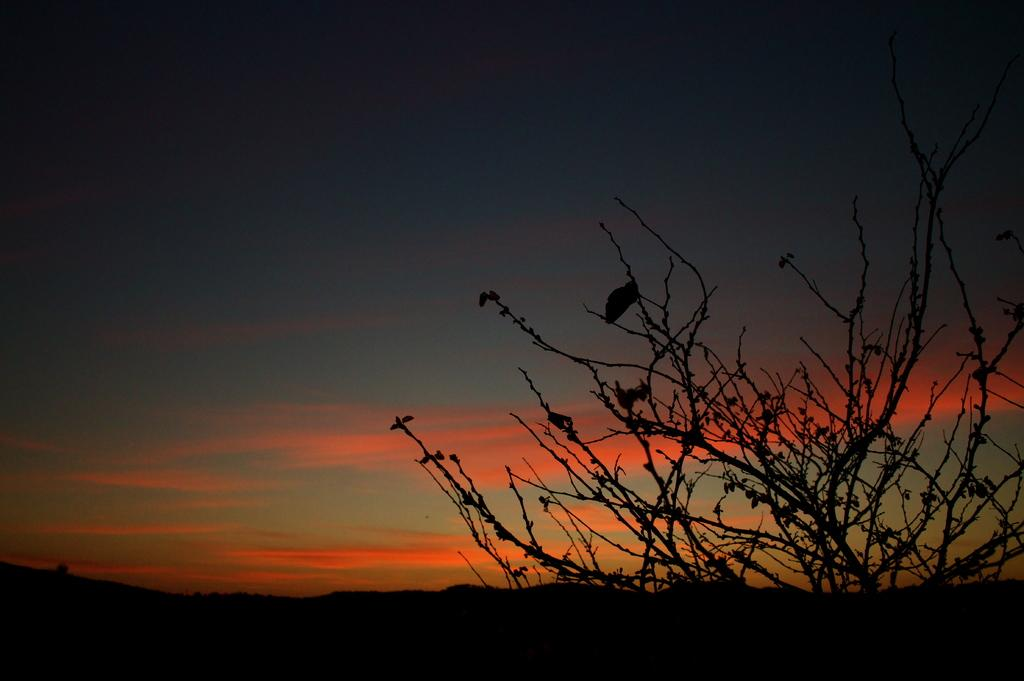What is located on the right side of the image? There is a tree with leaves in the foreground of the image. What can be seen in the background of the image? The sky is visible in the background of the image. What is present in the sky? There is a cloud in the sky. What is the condition of the tree in the image? The condition of the tree cannot be determined from the image alone, as it only shows the tree with leaves. --- Facts: 1. There is a person sitting on a bench in the image. 2. The person is reading a book. 3. The bench is in a park. 4. There are trees in the park. 5. There is a pond in the park. Absurd Topics: dance, parrot, mountain Conversation: What is the person in the image doing? The person is sitting on a bench and reading a book. Where is the bench located? The bench is in a park. What can be seen in the park besides the bench? There are trees and a pond in the park. Reasoning: Let's think step by step in order to produce the conversation. We start by identifying the main subject in the image, which is the person sitting on the bench. Then, we expand the conversation to include the person's activity (reading a book) and the location of the bench (in a park). Finally, we mention other features of the park (trees and a pond) that are visible in the image. Each question is designed to elicit a specific detail about the image that is known from the provided facts. Absurd Question/Answer: Can you see any parrots in the image? No, there are no parrots present in the image. 